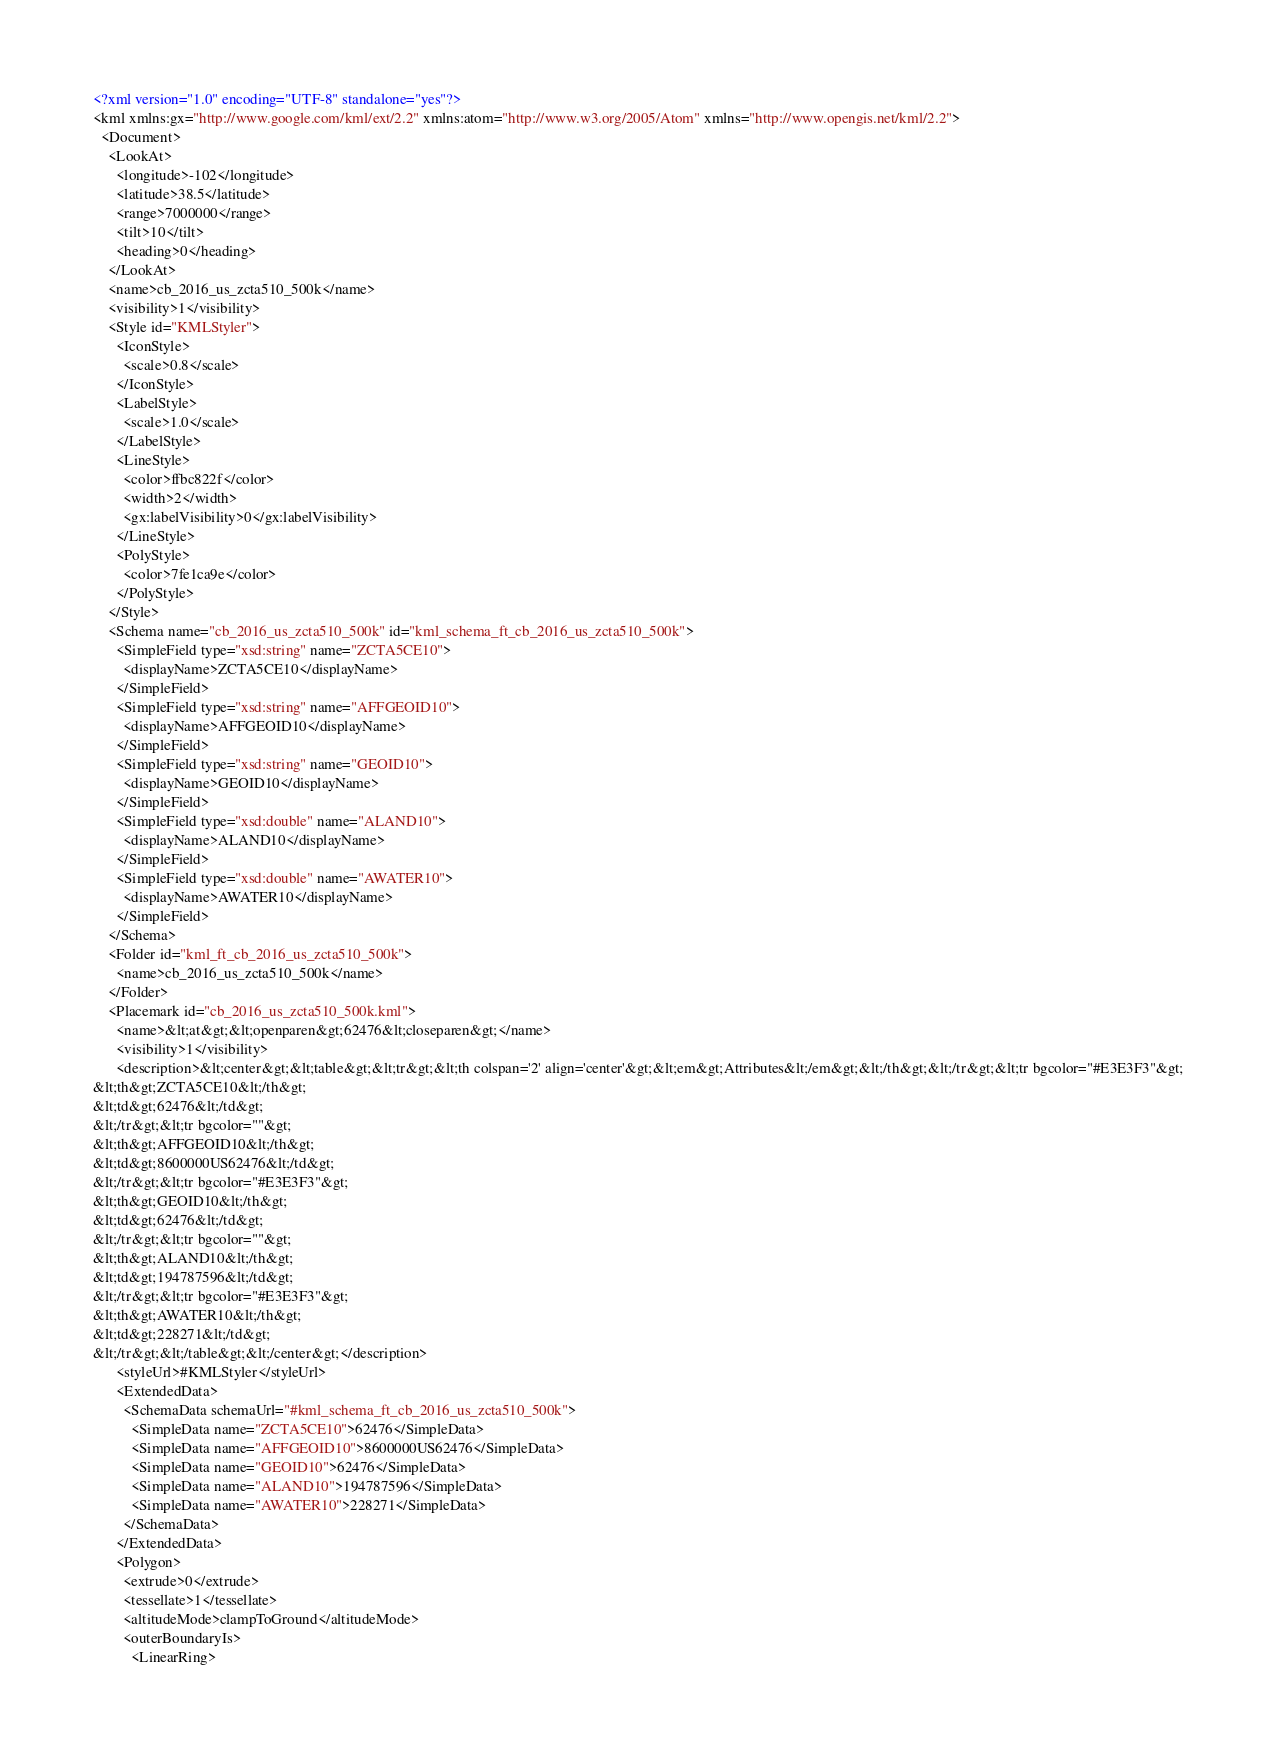<code> <loc_0><loc_0><loc_500><loc_500><_XML_><?xml version="1.0" encoding="UTF-8" standalone="yes"?>
<kml xmlns:gx="http://www.google.com/kml/ext/2.2" xmlns:atom="http://www.w3.org/2005/Atom" xmlns="http://www.opengis.net/kml/2.2">
  <Document>
    <LookAt>
      <longitude>-102</longitude>
      <latitude>38.5</latitude>
      <range>7000000</range>
      <tilt>10</tilt>
      <heading>0</heading>
    </LookAt>
    <name>cb_2016_us_zcta510_500k</name>
    <visibility>1</visibility>
    <Style id="KMLStyler">
      <IconStyle>
        <scale>0.8</scale>
      </IconStyle>
      <LabelStyle>
        <scale>1.0</scale>
      </LabelStyle>
      <LineStyle>
        <color>ffbc822f</color>
        <width>2</width>
        <gx:labelVisibility>0</gx:labelVisibility>
      </LineStyle>
      <PolyStyle>
        <color>7fe1ca9e</color>
      </PolyStyle>
    </Style>
    <Schema name="cb_2016_us_zcta510_500k" id="kml_schema_ft_cb_2016_us_zcta510_500k">
      <SimpleField type="xsd:string" name="ZCTA5CE10">
        <displayName>ZCTA5CE10</displayName>
      </SimpleField>
      <SimpleField type="xsd:string" name="AFFGEOID10">
        <displayName>AFFGEOID10</displayName>
      </SimpleField>
      <SimpleField type="xsd:string" name="GEOID10">
        <displayName>GEOID10</displayName>
      </SimpleField>
      <SimpleField type="xsd:double" name="ALAND10">
        <displayName>ALAND10</displayName>
      </SimpleField>
      <SimpleField type="xsd:double" name="AWATER10">
        <displayName>AWATER10</displayName>
      </SimpleField>
    </Schema>
    <Folder id="kml_ft_cb_2016_us_zcta510_500k">
      <name>cb_2016_us_zcta510_500k</name>
    </Folder>
    <Placemark id="cb_2016_us_zcta510_500k.kml">
      <name>&lt;at&gt;&lt;openparen&gt;62476&lt;closeparen&gt;</name>
      <visibility>1</visibility>
      <description>&lt;center&gt;&lt;table&gt;&lt;tr&gt;&lt;th colspan='2' align='center'&gt;&lt;em&gt;Attributes&lt;/em&gt;&lt;/th&gt;&lt;/tr&gt;&lt;tr bgcolor="#E3E3F3"&gt;
&lt;th&gt;ZCTA5CE10&lt;/th&gt;
&lt;td&gt;62476&lt;/td&gt;
&lt;/tr&gt;&lt;tr bgcolor=""&gt;
&lt;th&gt;AFFGEOID10&lt;/th&gt;
&lt;td&gt;8600000US62476&lt;/td&gt;
&lt;/tr&gt;&lt;tr bgcolor="#E3E3F3"&gt;
&lt;th&gt;GEOID10&lt;/th&gt;
&lt;td&gt;62476&lt;/td&gt;
&lt;/tr&gt;&lt;tr bgcolor=""&gt;
&lt;th&gt;ALAND10&lt;/th&gt;
&lt;td&gt;194787596&lt;/td&gt;
&lt;/tr&gt;&lt;tr bgcolor="#E3E3F3"&gt;
&lt;th&gt;AWATER10&lt;/th&gt;
&lt;td&gt;228271&lt;/td&gt;
&lt;/tr&gt;&lt;/table&gt;&lt;/center&gt;</description>
      <styleUrl>#KMLStyler</styleUrl>
      <ExtendedData>
        <SchemaData schemaUrl="#kml_schema_ft_cb_2016_us_zcta510_500k">
          <SimpleData name="ZCTA5CE10">62476</SimpleData>
          <SimpleData name="AFFGEOID10">8600000US62476</SimpleData>
          <SimpleData name="GEOID10">62476</SimpleData>
          <SimpleData name="ALAND10">194787596</SimpleData>
          <SimpleData name="AWATER10">228271</SimpleData>
        </SchemaData>
      </ExtendedData>
      <Polygon>
        <extrude>0</extrude>
        <tessellate>1</tessellate>
        <altitudeMode>clampToGround</altitudeMode>
        <outerBoundaryIs>
          <LinearRing></code> 